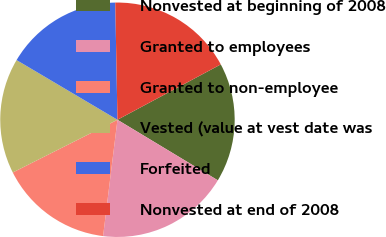Convert chart to OTSL. <chart><loc_0><loc_0><loc_500><loc_500><pie_chart><fcel>Nonvested at beginning of 2008<fcel>Granted to employees<fcel>Granted to non-employee<fcel>Vested (value at vest date was<fcel>Forfeited<fcel>Nonvested at end of 2008<nl><fcel>16.47%<fcel>18.32%<fcel>15.62%<fcel>15.93%<fcel>16.2%<fcel>17.47%<nl></chart> 